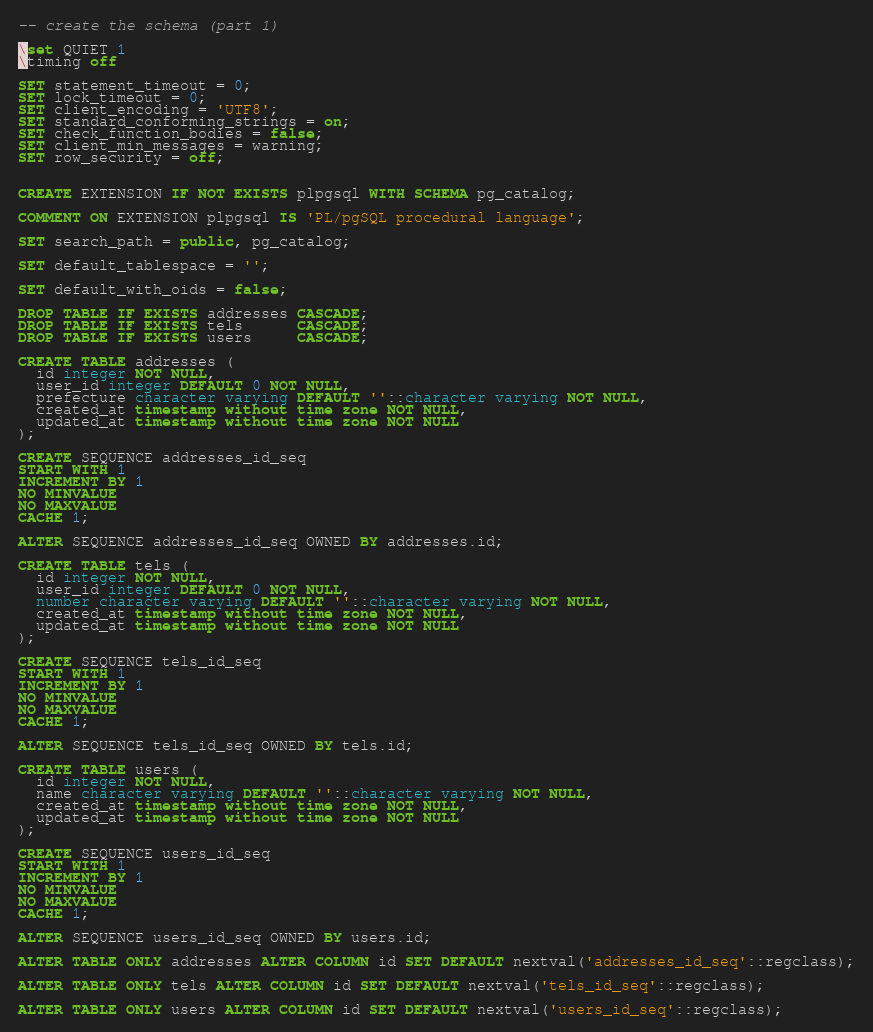Convert code to text. <code><loc_0><loc_0><loc_500><loc_500><_SQL_>-- create the schema (part 1)

\set QUIET 1
\timing off

SET statement_timeout = 0;
SET lock_timeout = 0;
SET client_encoding = 'UTF8';
SET standard_conforming_strings = on;
SET check_function_bodies = false;
SET client_min_messages = warning;
SET row_security = off;


CREATE EXTENSION IF NOT EXISTS plpgsql WITH SCHEMA pg_catalog;

COMMENT ON EXTENSION plpgsql IS 'PL/pgSQL procedural language';

SET search_path = public, pg_catalog;

SET default_tablespace = '';

SET default_with_oids = false;

DROP TABLE IF EXISTS addresses CASCADE;
DROP TABLE IF EXISTS tels      CASCADE;
DROP TABLE IF EXISTS users     CASCADE;

CREATE TABLE addresses (
  id integer NOT NULL,
  user_id integer DEFAULT 0 NOT NULL,
  prefecture character varying DEFAULT ''::character varying NOT NULL,
  created_at timestamp without time zone NOT NULL,
  updated_at timestamp without time zone NOT NULL
);

CREATE SEQUENCE addresses_id_seq
START WITH 1
INCREMENT BY 1
NO MINVALUE
NO MAXVALUE
CACHE 1;

ALTER SEQUENCE addresses_id_seq OWNED BY addresses.id;

CREATE TABLE tels (
  id integer NOT NULL,
  user_id integer DEFAULT 0 NOT NULL,
  number character varying DEFAULT ''::character varying NOT NULL,
  created_at timestamp without time zone NOT NULL,
  updated_at timestamp without time zone NOT NULL
);

CREATE SEQUENCE tels_id_seq
START WITH 1
INCREMENT BY 1
NO MINVALUE
NO MAXVALUE
CACHE 1;

ALTER SEQUENCE tels_id_seq OWNED BY tels.id;

CREATE TABLE users (
  id integer NOT NULL,
  name character varying DEFAULT ''::character varying NOT NULL,
  created_at timestamp without time zone NOT NULL,
  updated_at timestamp without time zone NOT NULL
);

CREATE SEQUENCE users_id_seq
START WITH 1
INCREMENT BY 1
NO MINVALUE
NO MAXVALUE
CACHE 1;

ALTER SEQUENCE users_id_seq OWNED BY users.id;

ALTER TABLE ONLY addresses ALTER COLUMN id SET DEFAULT nextval('addresses_id_seq'::regclass);

ALTER TABLE ONLY tels ALTER COLUMN id SET DEFAULT nextval('tels_id_seq'::regclass);

ALTER TABLE ONLY users ALTER COLUMN id SET DEFAULT nextval('users_id_seq'::regclass);
</code> 